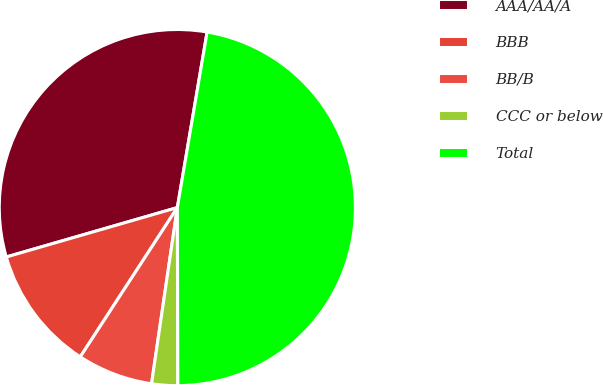Convert chart. <chart><loc_0><loc_0><loc_500><loc_500><pie_chart><fcel>AAA/AA/A<fcel>BBB<fcel>BB/B<fcel>CCC or below<fcel>Total<nl><fcel>32.15%<fcel>11.35%<fcel>6.86%<fcel>2.36%<fcel>47.28%<nl></chart> 